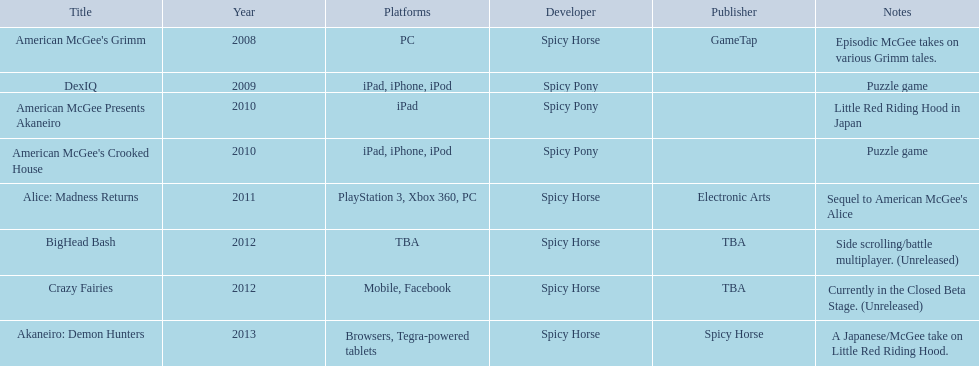What are the entire range of titles? American McGee's Grimm, DexIQ, American McGee Presents Akaneiro, American McGee's Crooked House, Alice: Madness Returns, BigHead Bash, Crazy Fairies, Akaneiro: Demon Hunters. On what platforms could they be found? PC, iPad, iPhone, iPod, iPad, iPad, iPhone, iPod, PlayStation 3, Xbox 360, PC, TBA, Mobile, Facebook, Browsers, Tegra-powered tablets. And which were solely on the ipad? American McGee Presents Akaneiro. 